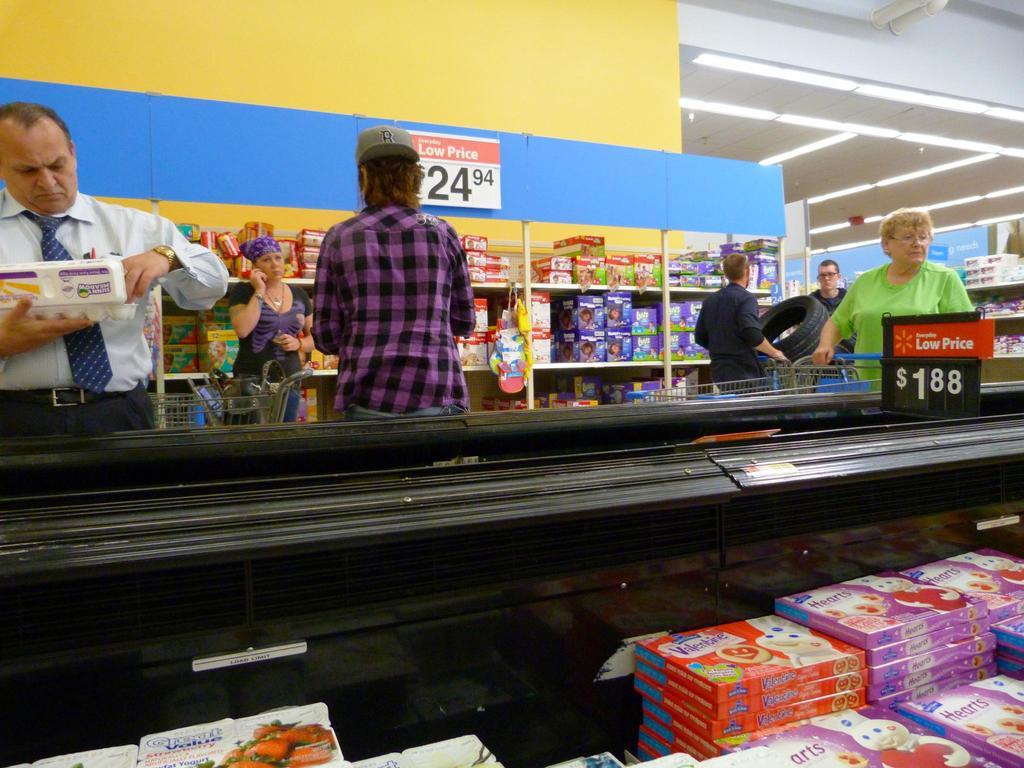What is the sale price on the wall?
Offer a very short reply. 24.94. What is the low price advertised in between the coolers?
Offer a very short reply. 24.94. 